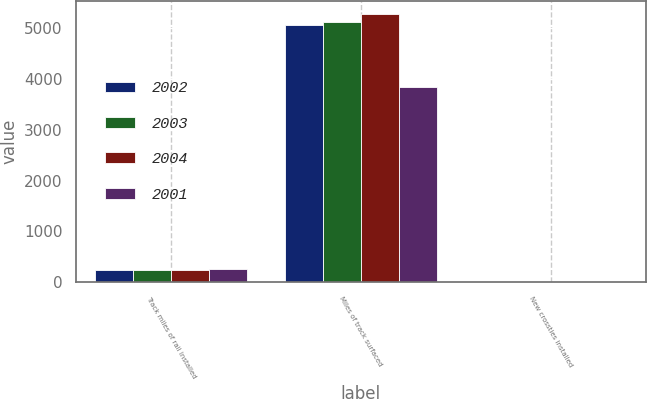<chart> <loc_0><loc_0><loc_500><loc_500><stacked_bar_chart><ecel><fcel>Track miles of rail installed<fcel>Miles of track surfaced<fcel>New crossties installed<nl><fcel>2002<fcel>246<fcel>5055<fcel>2.5<nl><fcel>2003<fcel>233<fcel>5105<fcel>2.8<nl><fcel>2004<fcel>235<fcel>5270<fcel>2.8<nl><fcel>2001<fcel>254<fcel>3836<fcel>1.5<nl></chart> 